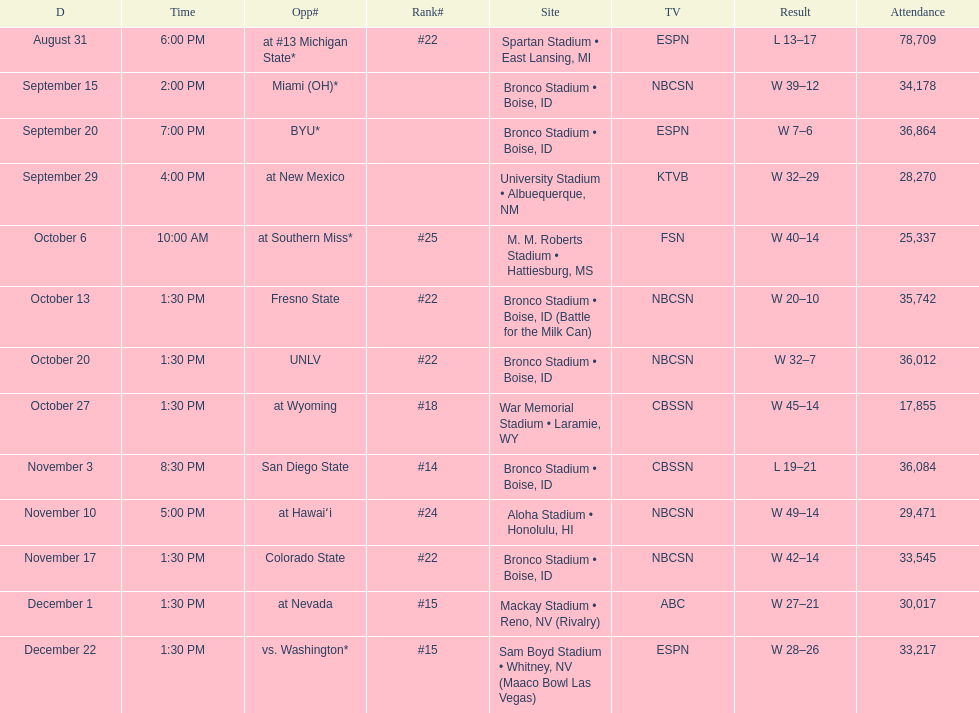Could you help me parse every detail presented in this table? {'header': ['D', 'Time', 'Opp#', 'Rank#', 'Site', 'TV', 'Result', 'Attendance'], 'rows': [['August 31', '6:00 PM', 'at\xa0#13\xa0Michigan State*', '#22', 'Spartan Stadium • East Lansing, MI', 'ESPN', 'L\xa013–17', '78,709'], ['September 15', '2:00 PM', 'Miami (OH)*', '', 'Bronco Stadium • Boise, ID', 'NBCSN', 'W\xa039–12', '34,178'], ['September 20', '7:00 PM', 'BYU*', '', 'Bronco Stadium • Boise, ID', 'ESPN', 'W\xa07–6', '36,864'], ['September 29', '4:00 PM', 'at\xa0New Mexico', '', 'University Stadium • Albuequerque, NM', 'KTVB', 'W\xa032–29', '28,270'], ['October 6', '10:00 AM', 'at\xa0Southern Miss*', '#25', 'M. M. Roberts Stadium • Hattiesburg, MS', 'FSN', 'W\xa040–14', '25,337'], ['October 13', '1:30 PM', 'Fresno State', '#22', 'Bronco Stadium • Boise, ID (Battle for the Milk Can)', 'NBCSN', 'W\xa020–10', '35,742'], ['October 20', '1:30 PM', 'UNLV', '#22', 'Bronco Stadium • Boise, ID', 'NBCSN', 'W\xa032–7', '36,012'], ['October 27', '1:30 PM', 'at\xa0Wyoming', '#18', 'War Memorial Stadium • Laramie, WY', 'CBSSN', 'W\xa045–14', '17,855'], ['November 3', '8:30 PM', 'San Diego State', '#14', 'Bronco Stadium • Boise, ID', 'CBSSN', 'L\xa019–21', '36,084'], ['November 10', '5:00 PM', 'at\xa0Hawaiʻi', '#24', 'Aloha Stadium • Honolulu, HI', 'NBCSN', 'W\xa049–14', '29,471'], ['November 17', '1:30 PM', 'Colorado State', '#22', 'Bronco Stadium • Boise, ID', 'NBCSN', 'W\xa042–14', '33,545'], ['December 1', '1:30 PM', 'at\xa0Nevada', '#15', 'Mackay Stadium • Reno, NV (Rivalry)', 'ABC', 'W\xa027–21', '30,017'], ['December 22', '1:30 PM', 'vs.\xa0Washington*', '#15', 'Sam Boyd Stadium • Whitney, NV (Maaco Bowl Las Vegas)', 'ESPN', 'W\xa028–26', '33,217']]} Opponent broncos faced next after unlv Wyoming. 